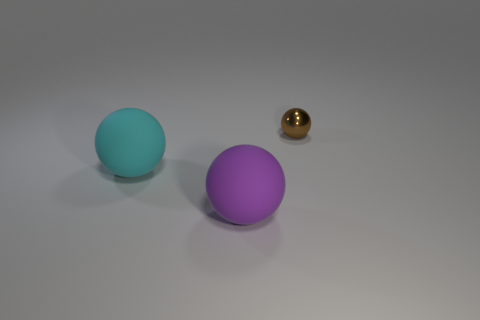What materials do the objects in this image seem to be made of? The objects in the image appear to be made of different materials. The aqua and the purple spheres have a matte appearance, suggesting they could be made of a clay or plastic material, while the small brown sphere has a shiny, reflective surface which is indicative of a polished metal or glass. 